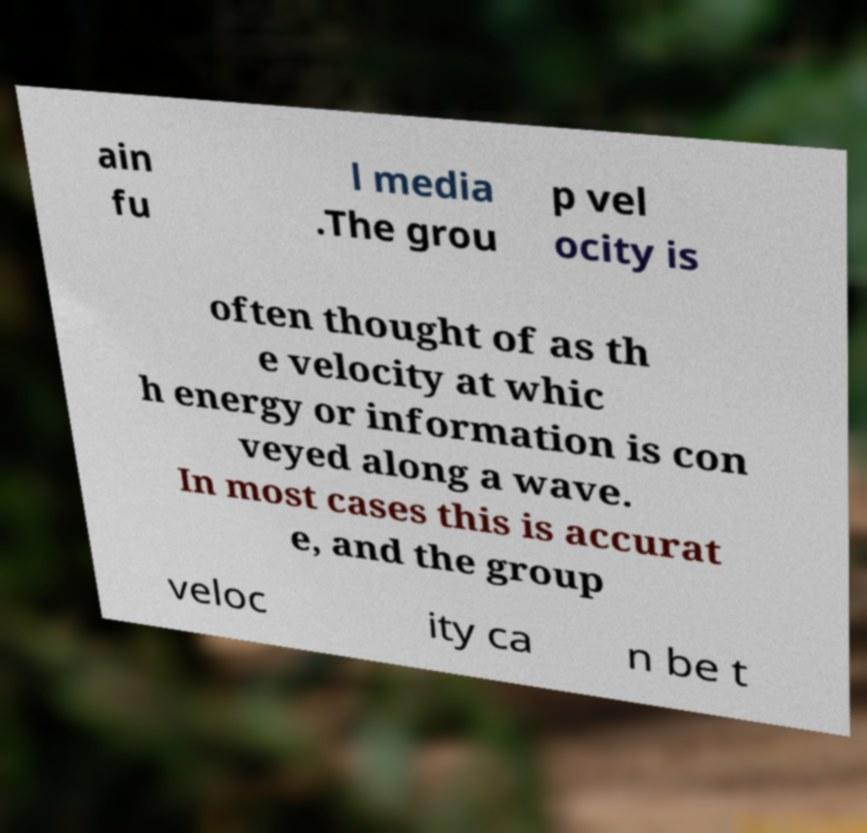Can you accurately transcribe the text from the provided image for me? ain fu l media .The grou p vel ocity is often thought of as th e velocity at whic h energy or information is con veyed along a wave. In most cases this is accurat e, and the group veloc ity ca n be t 